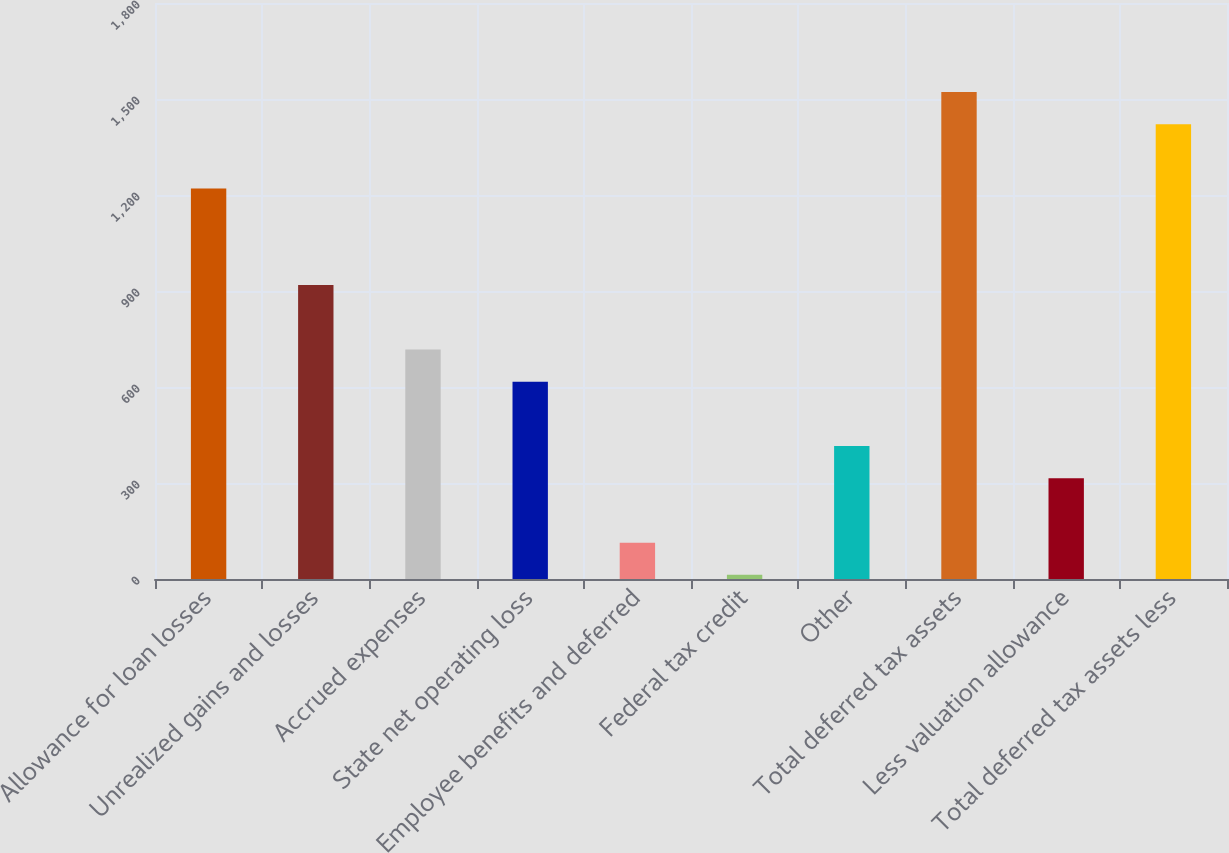Convert chart to OTSL. <chart><loc_0><loc_0><loc_500><loc_500><bar_chart><fcel>Allowance for loan losses<fcel>Unrealized gains and losses<fcel>Accrued expenses<fcel>State net operating loss<fcel>Employee benefits and deferred<fcel>Federal tax credit<fcel>Other<fcel>Total deferred tax assets<fcel>Less valuation allowance<fcel>Total deferred tax assets less<nl><fcel>1220.2<fcel>918.4<fcel>717.2<fcel>616.6<fcel>113.6<fcel>13<fcel>415.4<fcel>1522<fcel>314.8<fcel>1421.4<nl></chart> 